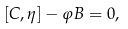<formula> <loc_0><loc_0><loc_500><loc_500>[ C , \eta ] - \varphi B = 0 ,</formula> 